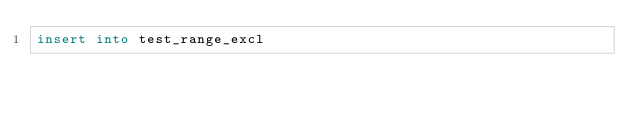Convert code to text. <code><loc_0><loc_0><loc_500><loc_500><_SQL_>insert into test_range_excl</code> 